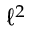<formula> <loc_0><loc_0><loc_500><loc_500>\ell ^ { 2 }</formula> 